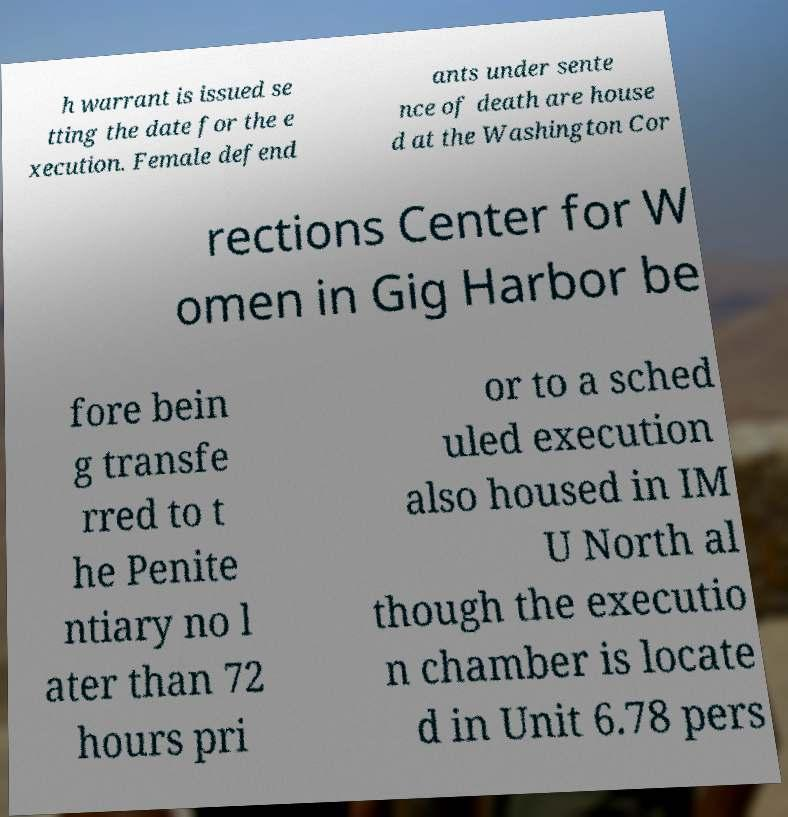For documentation purposes, I need the text within this image transcribed. Could you provide that? h warrant is issued se tting the date for the e xecution. Female defend ants under sente nce of death are house d at the Washington Cor rections Center for W omen in Gig Harbor be fore bein g transfe rred to t he Penite ntiary no l ater than 72 hours pri or to a sched uled execution also housed in IM U North al though the executio n chamber is locate d in Unit 6.78 pers 